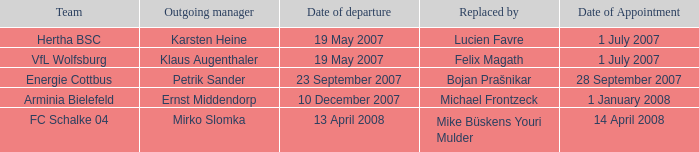On which date was the manager preceding lucien favre appointed? 1 July 2007. 